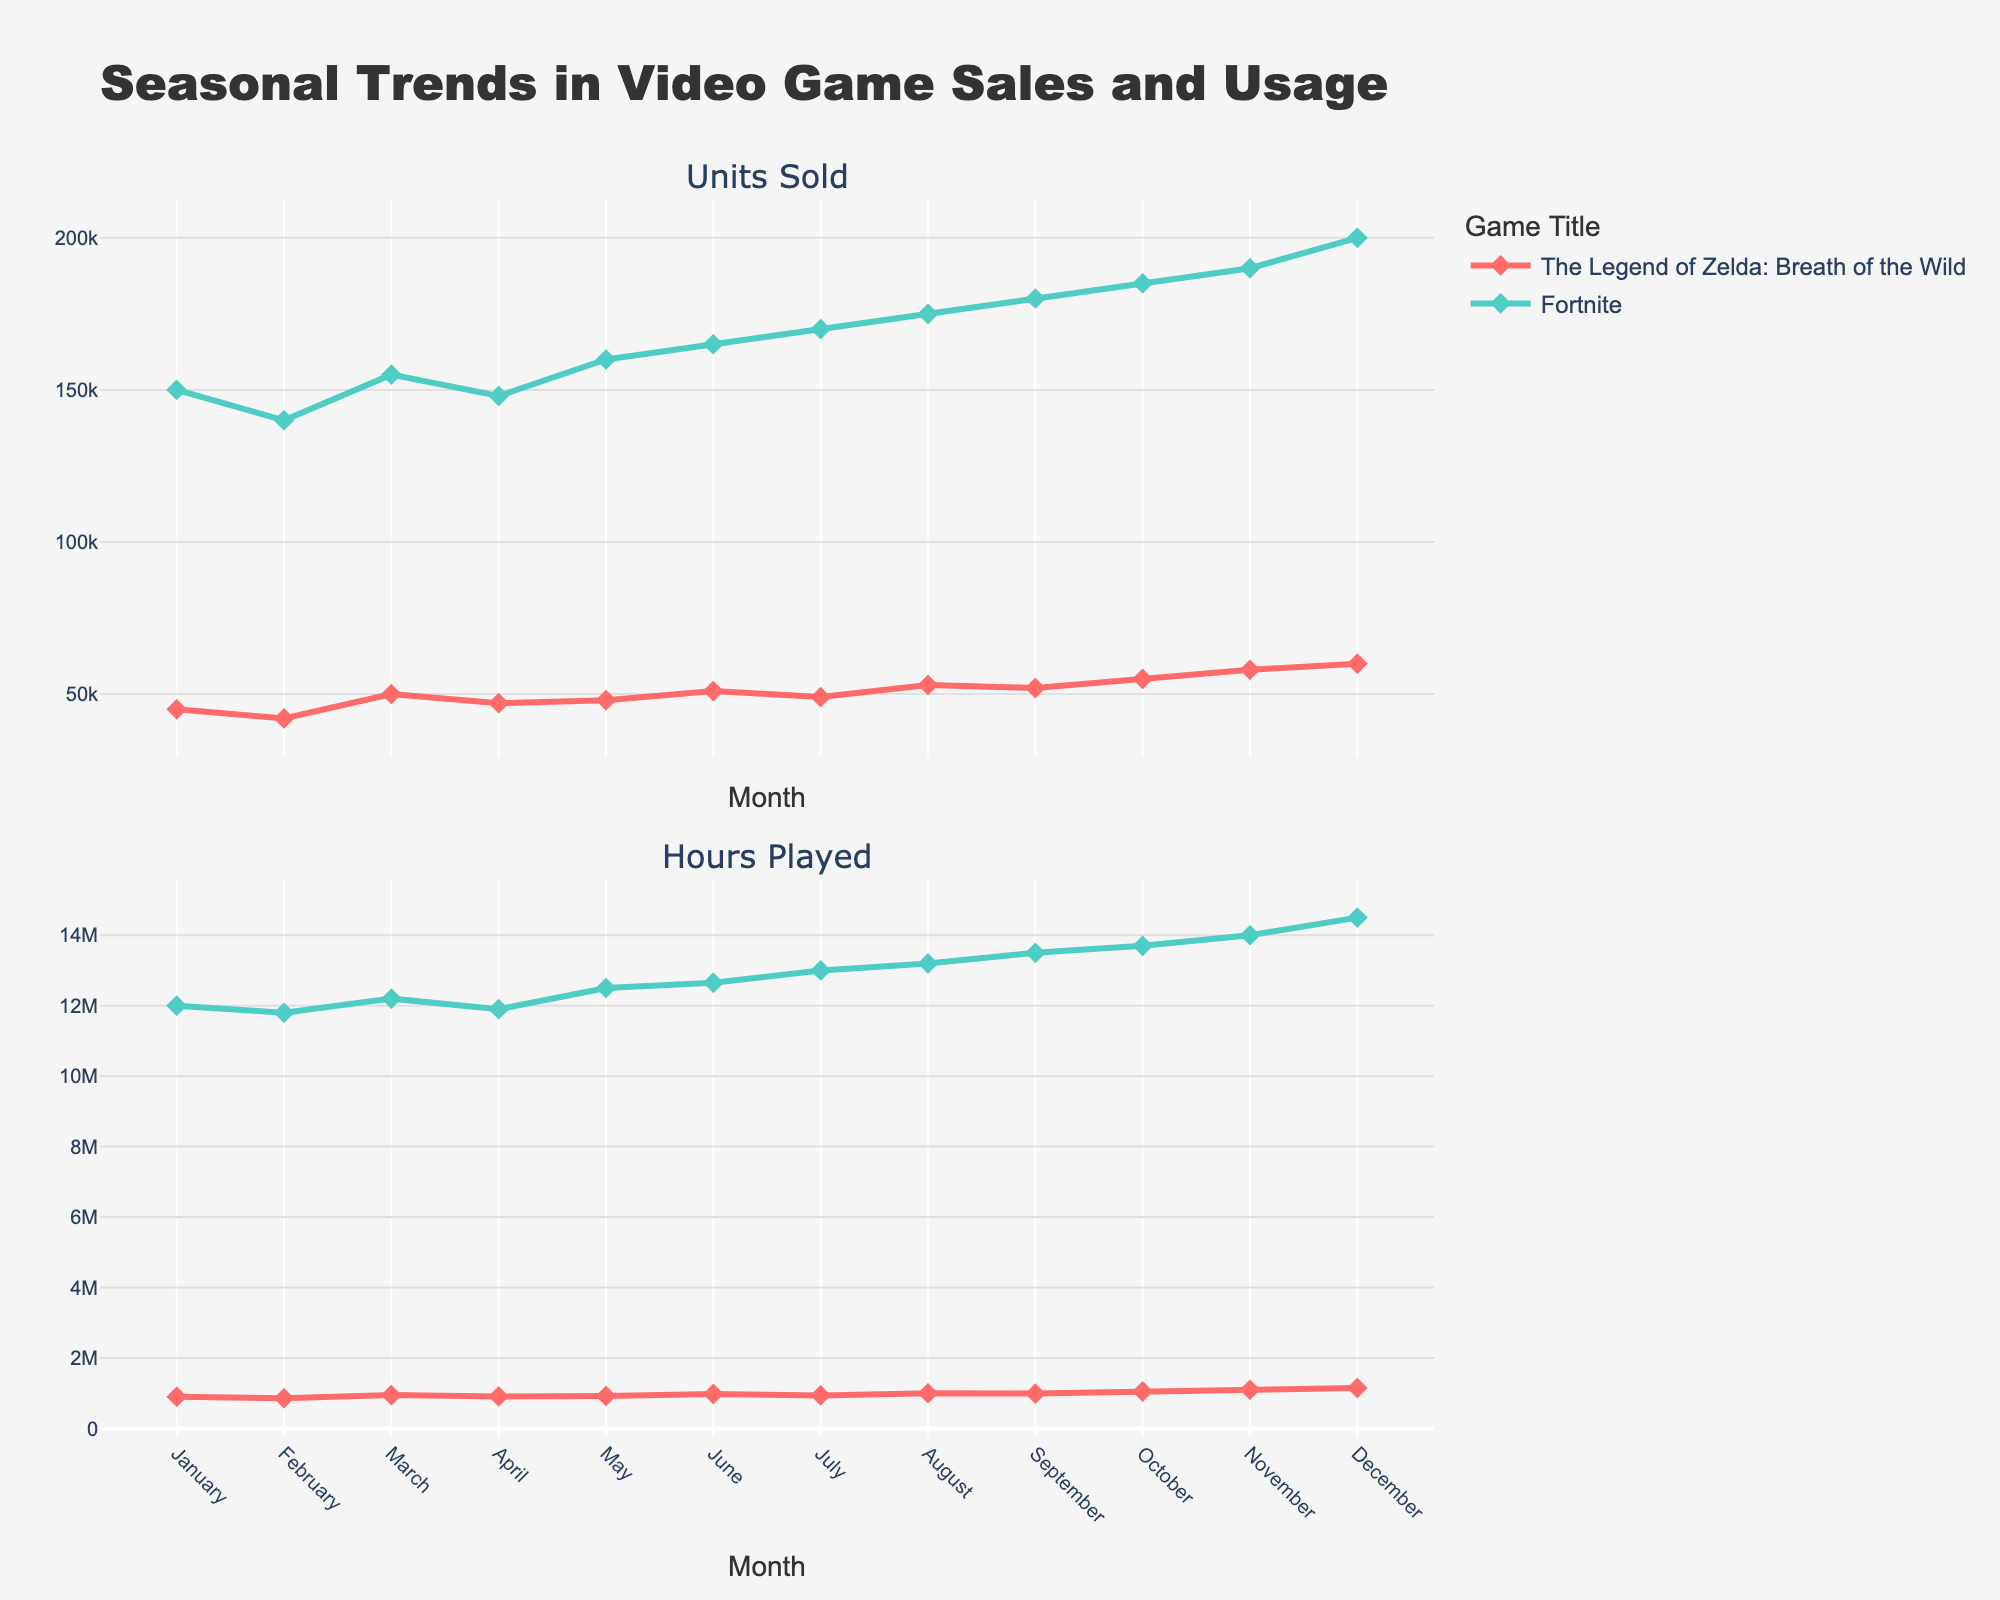How are the months represented in the plot? The months are represented on the x-axis of the plot, which spans from January to December. Each month has its own tick mark and is labeled clearly.
Answer: January to December What is the trend in units sold for "The Legend of Zelda: Breath of the Wild"? Observing the plot, the units sold for "The Legend of Zelda: Breath of the Wild" show a general increasing trend from January to December, starting at 45,000 units in January and rising to 60,000 units in December.
Answer: Increasing trend Which game had higher units sold in November? Looking at the plot, the units sold for "The Legend of Zelda: Breath of the Wild" in November are 58,000, whereas for "Fortnite," it's 190,000. Since 190,000 is greater than 58,000, "Fortnite" had higher units sold in November.
Answer: Fortnite What's the difference in hours played between "The Legend of Zelda: Breath of the Wild" and "Fortnite" in October? In October, "The Legend of Zelda: Breath of the Wild" had 1,050,000 hours played and "Fortnite" had 13,700,000 hours played. The difference is 13,700,000 - 1,050,000, which is 12,650,000 hours.
Answer: 12,650,000 hours What is the average number of units sold for "The Legend of Zelda: Breath of the Wild" over the year? Adding up the units sold each month for "The Legend of Zelda: Breath of the Wild" (45,000 + 42,000 + 50,000 + 47,000 + 48,000 + 51,000 + 49,000 + 53,000 + 52,000 + 55,000 + 58,000 + 60,000) gives a total of 610,000. Dividing this by 12 months results in an average of 50,833 units sold per month.
Answer: 50,833 units Which month shows the highest hours played for "Fortnite"? Referring to the plot, December shows the highest hours played for "Fortnite," with a total of 14,500,000 hours.
Answer: December Is there a noticeable seasonal trend in the hours played for "The Legend of Zelda: Breath of the Wild"? The plot shows a general increasing trend in hours played for "The Legend of Zelda: Breath of the Wild" from January (900,000 hours) to December (1,150,000 hours), with slight dips in February and April.
Answer: Yes, increasing trend During which month did "The Legend of Zelda: Breath of the Wild" have equal units sold and hours played? There is no month where the units sold and hours played for "The Legend of Zelda: Breath of the Wild" are equal, as the number of units sold and hours played are significantly different scales.
Answer: Never How does the trend in units sold for "Fortnite" compare to "The Legend of Zelda: Breath of the Wild"? The units sold for "Fortnite" also shows an increasing trend from January to December, similar to "The Legend of Zelda: Breath of the Wild." However, the overall numbers for "Fortnite" are significantly higher each month.
Answer: Similar increasing trend but higher numbers 